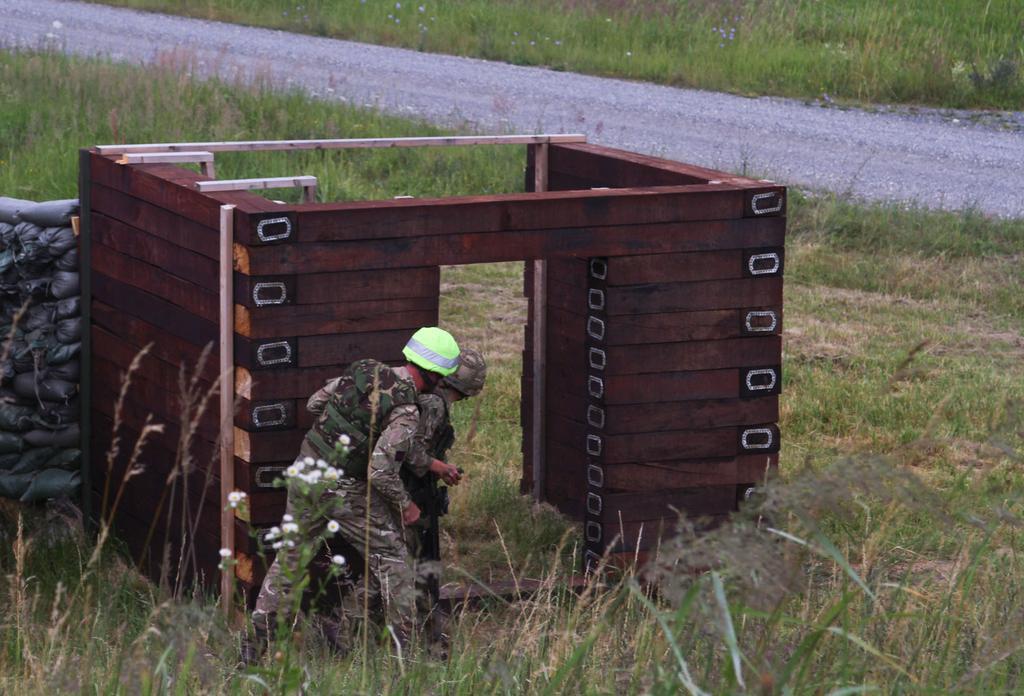Describe this image in one or two sentences. In this image, we can see two people are in a military uniform. They are wearing helmets. Here we can see wooden block, carry bags. Here we can see grass, plants, flowers and road. 